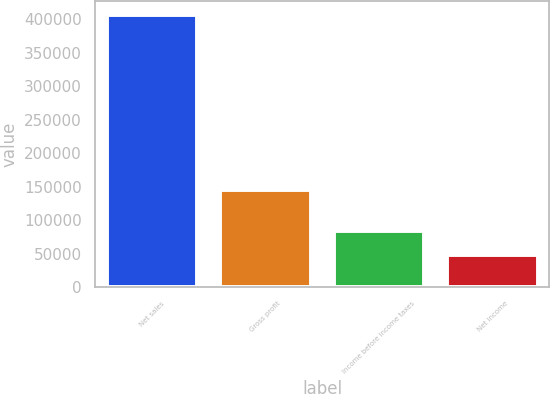Convert chart. <chart><loc_0><loc_0><loc_500><loc_500><bar_chart><fcel>Net sales<fcel>Gross profit<fcel>Income before income taxes<fcel>Net income<nl><fcel>406850<fcel>144705<fcel>83826.5<fcel>47935<nl></chart> 